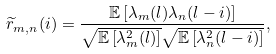Convert formula to latex. <formula><loc_0><loc_0><loc_500><loc_500>\widetilde { r } _ { m , n } ( i ) = \frac { \mathbb { E } \left [ \lambda _ { m } ( l ) \lambda _ { n } ( l - i ) \right ] } { \sqrt { \mathbb { E } \left [ \lambda _ { m } ^ { 2 } ( l ) \right ] } \sqrt { \mathbb { E } \left [ \lambda _ { n } ^ { 2 } ( l - i ) \right ] } } ,</formula> 